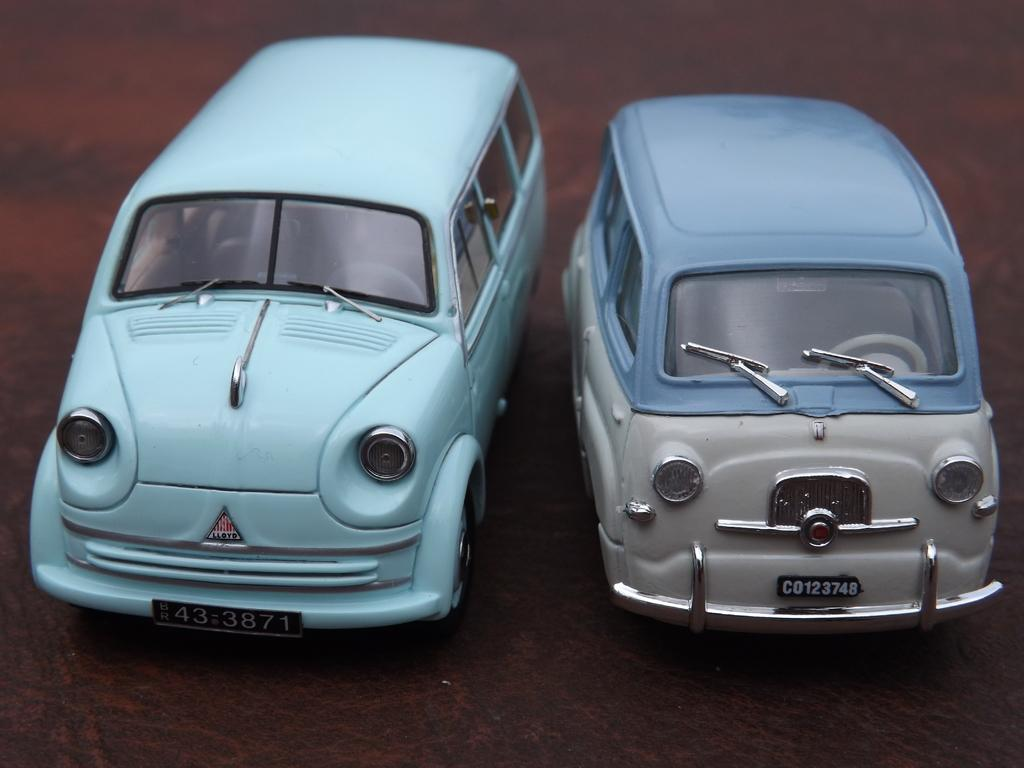What type of toys are present in the image? There are toy cars in the image. Where are the toy cars located? The toy cars are placed on a surface. What is the taste of the toy cars in the image? Toy cars do not have a taste, as they are inanimate objects and not edible. 